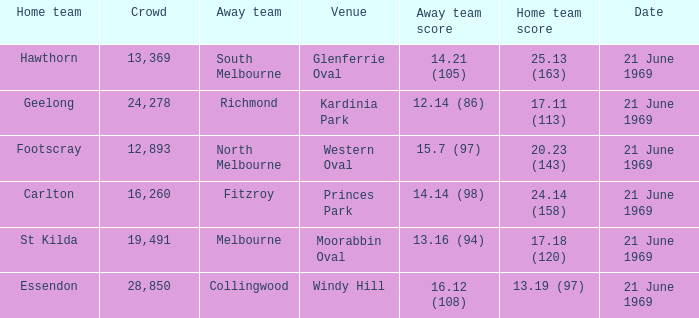What is Essendon's home team that has an away crowd size larger than 19,491? Collingwood. 